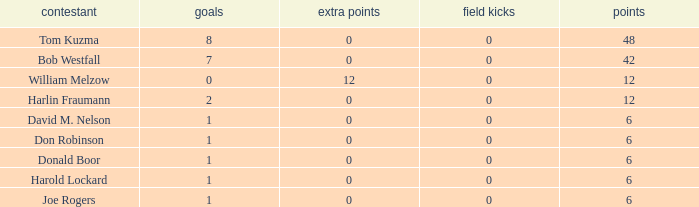Name the points for donald boor 6.0. 